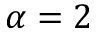<formula> <loc_0><loc_0><loc_500><loc_500>\alpha = 2</formula> 